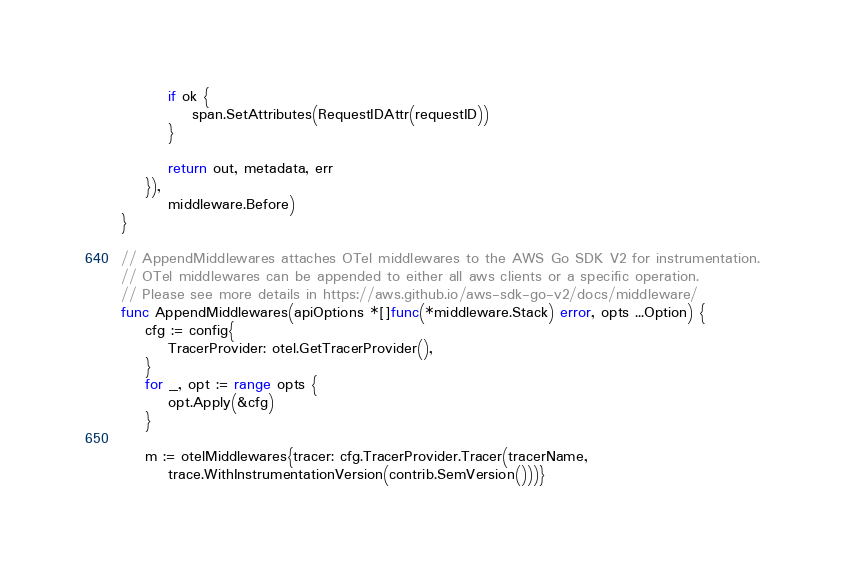<code> <loc_0><loc_0><loc_500><loc_500><_Go_>		if ok {
			span.SetAttributes(RequestIDAttr(requestID))
		}

		return out, metadata, err
	}),
		middleware.Before)
}

// AppendMiddlewares attaches OTel middlewares to the AWS Go SDK V2 for instrumentation.
// OTel middlewares can be appended to either all aws clients or a specific operation.
// Please see more details in https://aws.github.io/aws-sdk-go-v2/docs/middleware/
func AppendMiddlewares(apiOptions *[]func(*middleware.Stack) error, opts ...Option) {
	cfg := config{
		TracerProvider: otel.GetTracerProvider(),
	}
	for _, opt := range opts {
		opt.Apply(&cfg)
	}

	m := otelMiddlewares{tracer: cfg.TracerProvider.Tracer(tracerName,
		trace.WithInstrumentationVersion(contrib.SemVersion()))}</code> 